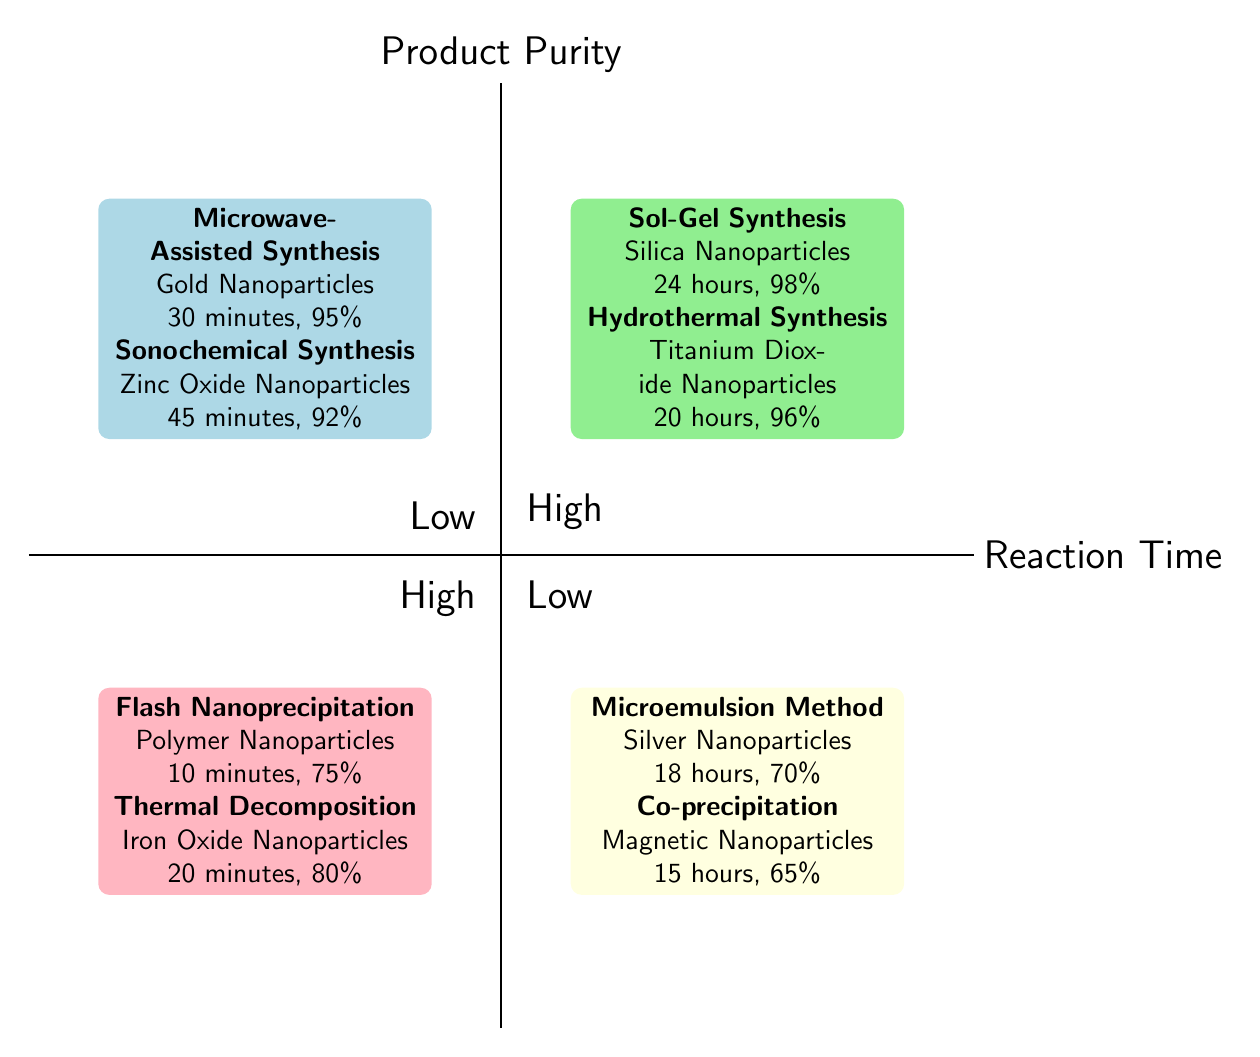What type of nanomaterial is produced by Sol-Gel Synthesis? According to the diagram, under the "High Reaction Time - High Product Purity" quadrant, the Sol-Gel Synthesis process produces Silica Nanoparticles.
Answer: Silica Nanoparticles What is the reaction time for Microwave-Assisted Synthesis? The diagram indicates that the reaction time for Microwave-Assisted Synthesis, located in the "Low Reaction Time - High Product Purity" quadrant, is 30 minutes.
Answer: 30 minutes Which nanomaterial has the highest product purity among those listed? Reviewing the diagram, the highest product purity is 98% for Silica Nanoparticles produced by Sol-Gel Synthesis in the "High Reaction Time - High Product Purity" quadrant.
Answer: 98% How many examples are shown in the "Low Reaction Time - Low Product Purity" quadrant? The diagram highlights two examples in the "Low Reaction Time - Low Product Purity" quadrant: Flash Nanoprecipitation and Thermal Decomposition. Thus, there are two.
Answer: 2 What is the product purity of Titanium Dioxide Nanoparticles? From the diagram, the product purity for Titanium Dioxide Nanoparticles, produced via Hydrothermal Synthesis in the "High Reaction Time - High Product Purity" quadrant, is 96%.
Answer: 96% Which synthesis method has the least reaction time? The diagram shows Flash Nanoprecipitation with the least reaction time of 10 minutes in the "Low Reaction Time - Low Product Purity" quadrant.
Answer: 10 minutes What is the relationship between reaction time and product purity for Silver Nanoparticles? The diagram illustrates that Silver Nanoparticles have a relatively high reaction time of 18 hours and a lower product purity of 70%, placing them in the "High Reaction Time - Low Product Purity" quadrant.
Answer: High Reaction Time - Low Product Purity Which quadrant contains the highest concentration of nanomaterial examples? By analyzing the diagram, both "High Reaction Time - High Product Purity" and "High Reaction Time - Low Product Purity" quadrants each have two examples, while the others have the same count. Thus, the maximum concentration is equally in two quadrants.
Answer: Two quadrants 